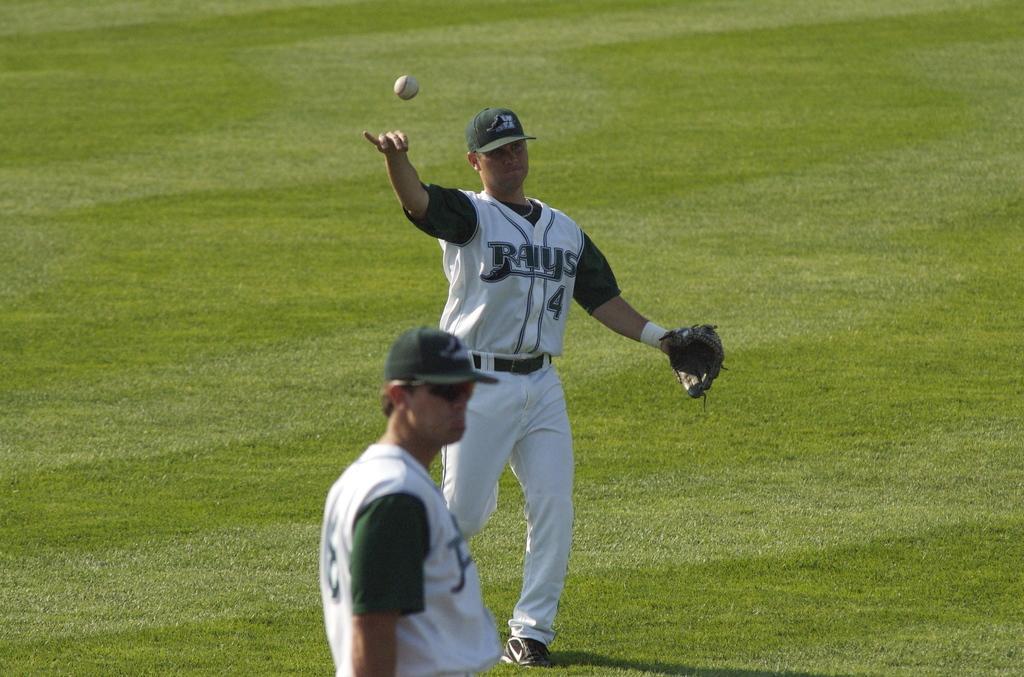In one or two sentences, can you explain what this image depicts? In this picture there is a man, he might be walking. In the foreground there is a man standing. At the top there is a ball in the air. At the bottom there is grass. 